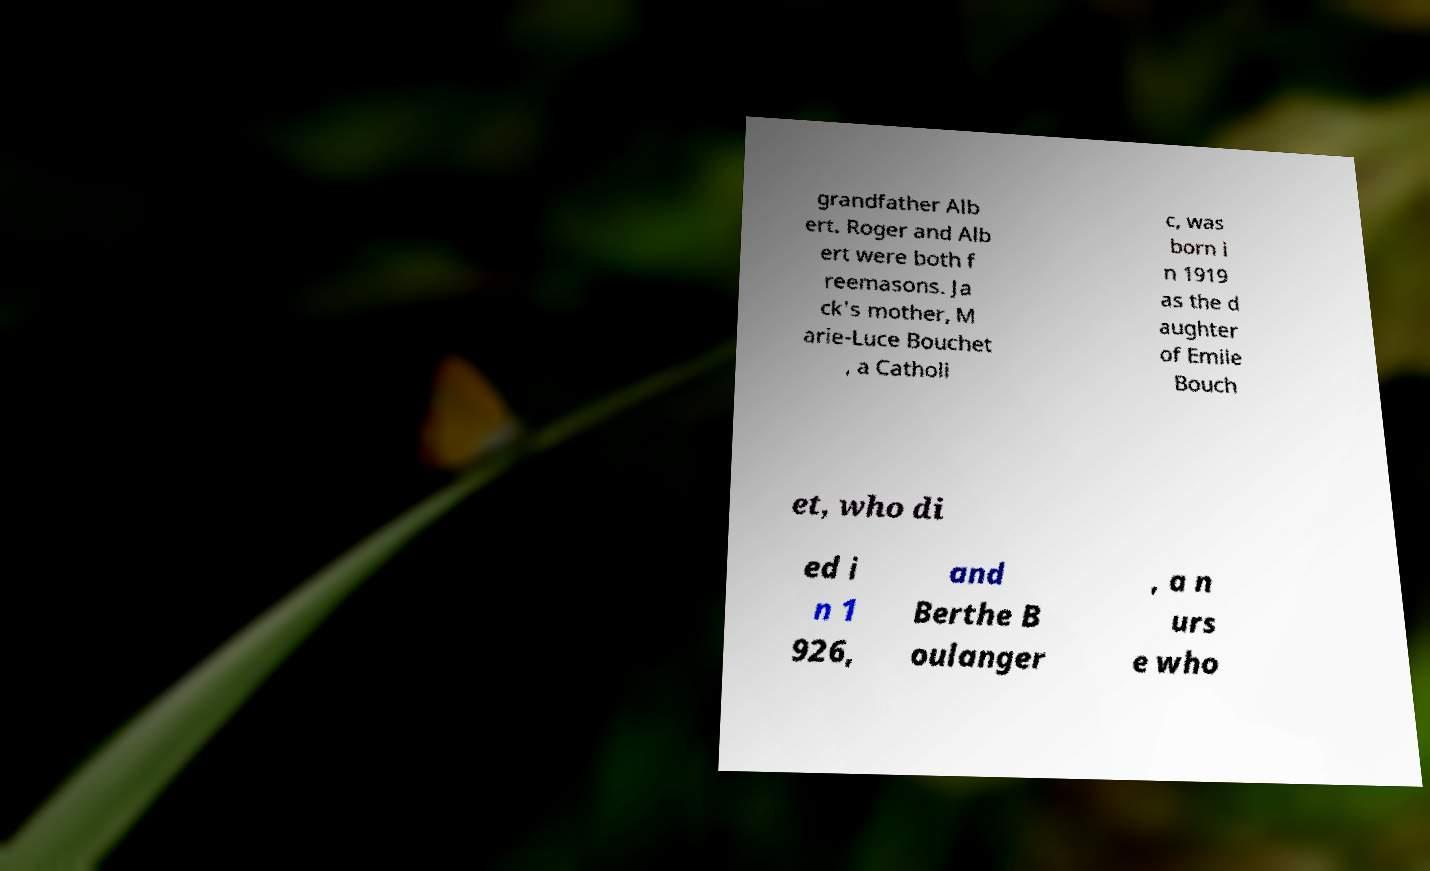Please identify and transcribe the text found in this image. grandfather Alb ert. Roger and Alb ert were both f reemasons. Ja ck's mother, M arie-Luce Bouchet , a Catholi c, was born i n 1919 as the d aughter of Emile Bouch et, who di ed i n 1 926, and Berthe B oulanger , a n urs e who 